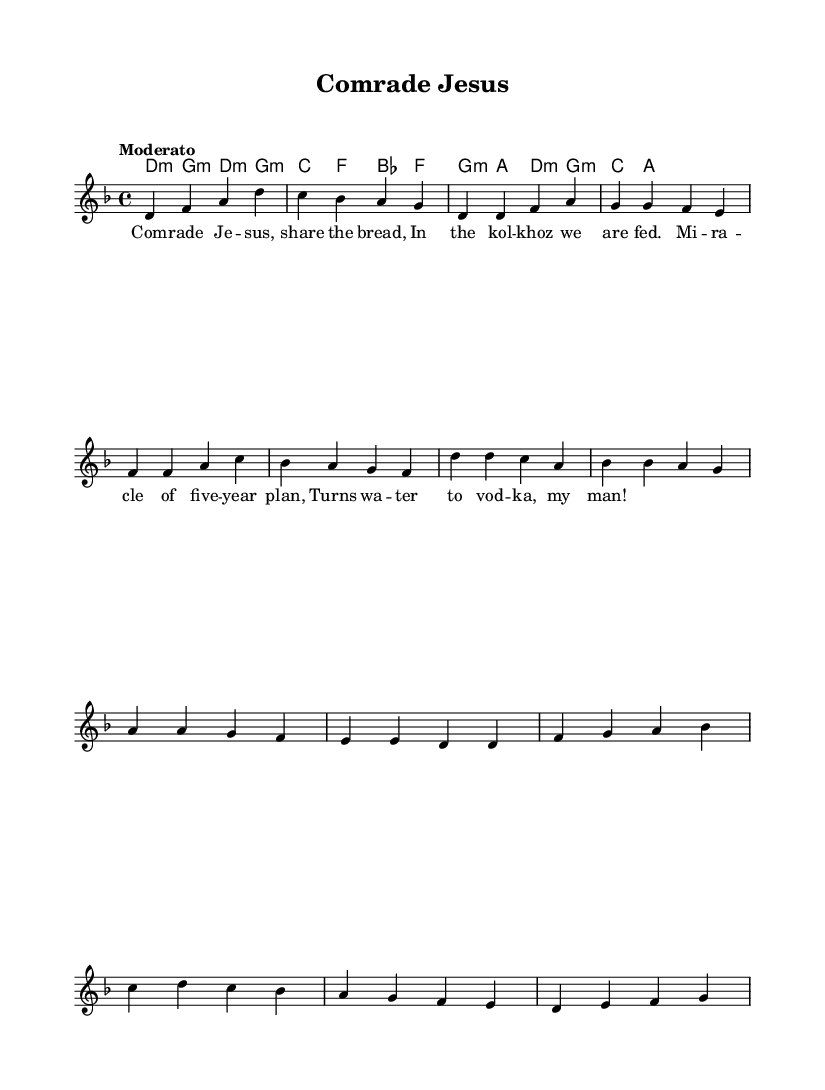What is the key signature of this music? The key signature indicates D minor, which has one flat. This is shown in the global settings at the beginning of the score.
Answer: D minor What is the time signature of this piece? The time signature is 4/4, which means there are four beats in each measure, as seen in the global settings.
Answer: 4/4 What is the tempo marking for this composition? The tempo marking is "Moderato," indicating a moderate speed, and is specified in the global section of the score.
Answer: Moderato How many verses are present in this sheet music? The sheet music contains one verse, which is evident by the structure of the melody and the presence of only one text section designated as "Verse 1."
Answer: One What is the name of the chorus in this music? The chorus is derived from the repeated lyrical section 'd' and melodic structure after the first verse, which is indicated as "Chorus" in the sheet.
Answer: Chorus What rhythmic structure does the bridge section adhere to? The bridge section follows a consistent rhythm that aligns with the measures defined, allowing for a smooth transition, as shown by the specific grouping of notes.
Answer: Consistent rhythm How does the theme of this song connect with the Soviet comedic tradition? The lyrics reflect satirical elements such as a miracle relating to collective farming and a whimsical transformation of water to vodka, embodying a blend of humor with religious undertones typically seen in Soviet-era comedic performances.
Answer: Satirical elements 